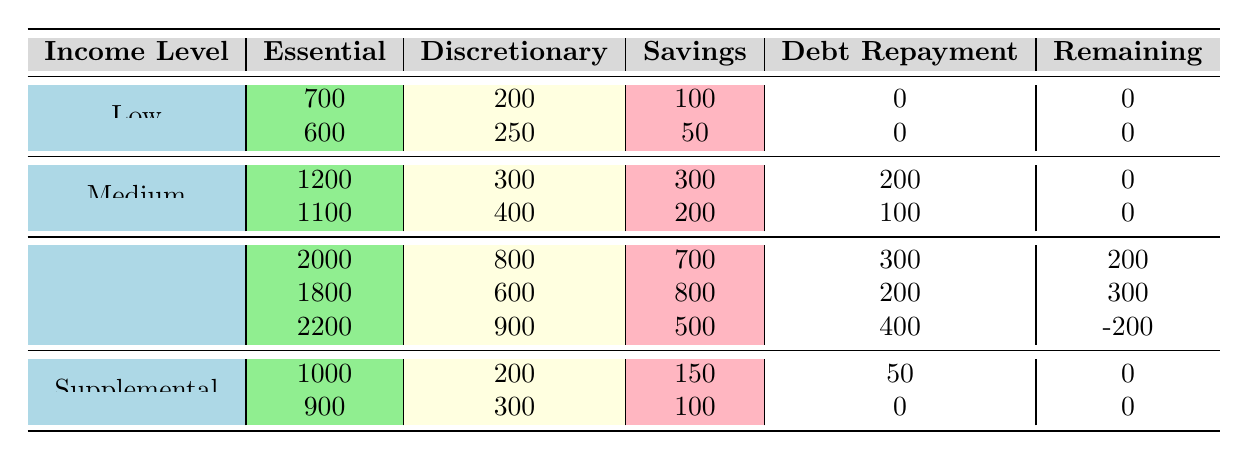What are the essential expenses for the highest income level? Referring to the rows for the High-income level, the highest essential expense is 2200.
Answer: 2200 How much is saved by individuals with low income and the highest discretionary expense? The low-income group with the highest discretionary expense of 250 saves 50.
Answer: 50 Is there a case where the remaining balance is negative? Yes, for the High-income level with essential expenses of 2200 and discretionary expenses of 900, the remaining balance is -200.
Answer: Yes What is the total savings for individuals in the medium income level? For the medium income level, savings of 300 and 200 are summed: 300 + 200 = 500.
Answer: 500 Which income level shows the highest essential expenses? Among the income levels, the High-income level shows the highest essential expenses of 2200.
Answer: High What is the average debt repayment for the high-income level? The high-income debt repayments are 300, 200, and 400, which sum up to 900. There are three entries, so the average is 900/3 = 300.
Answer: 300 Which income level has the least remaining balance, and what is that balance? The High-income level with an essential expense of 2200 and discretionary expense of 900 shows a remaining balance of -200, which is the lowest balance.
Answer: High, -200 Is it true that all individuals at the low income level do not have any debt repayment? Yes, both low-income entries have zero for debt repayment.
Answer: Yes 